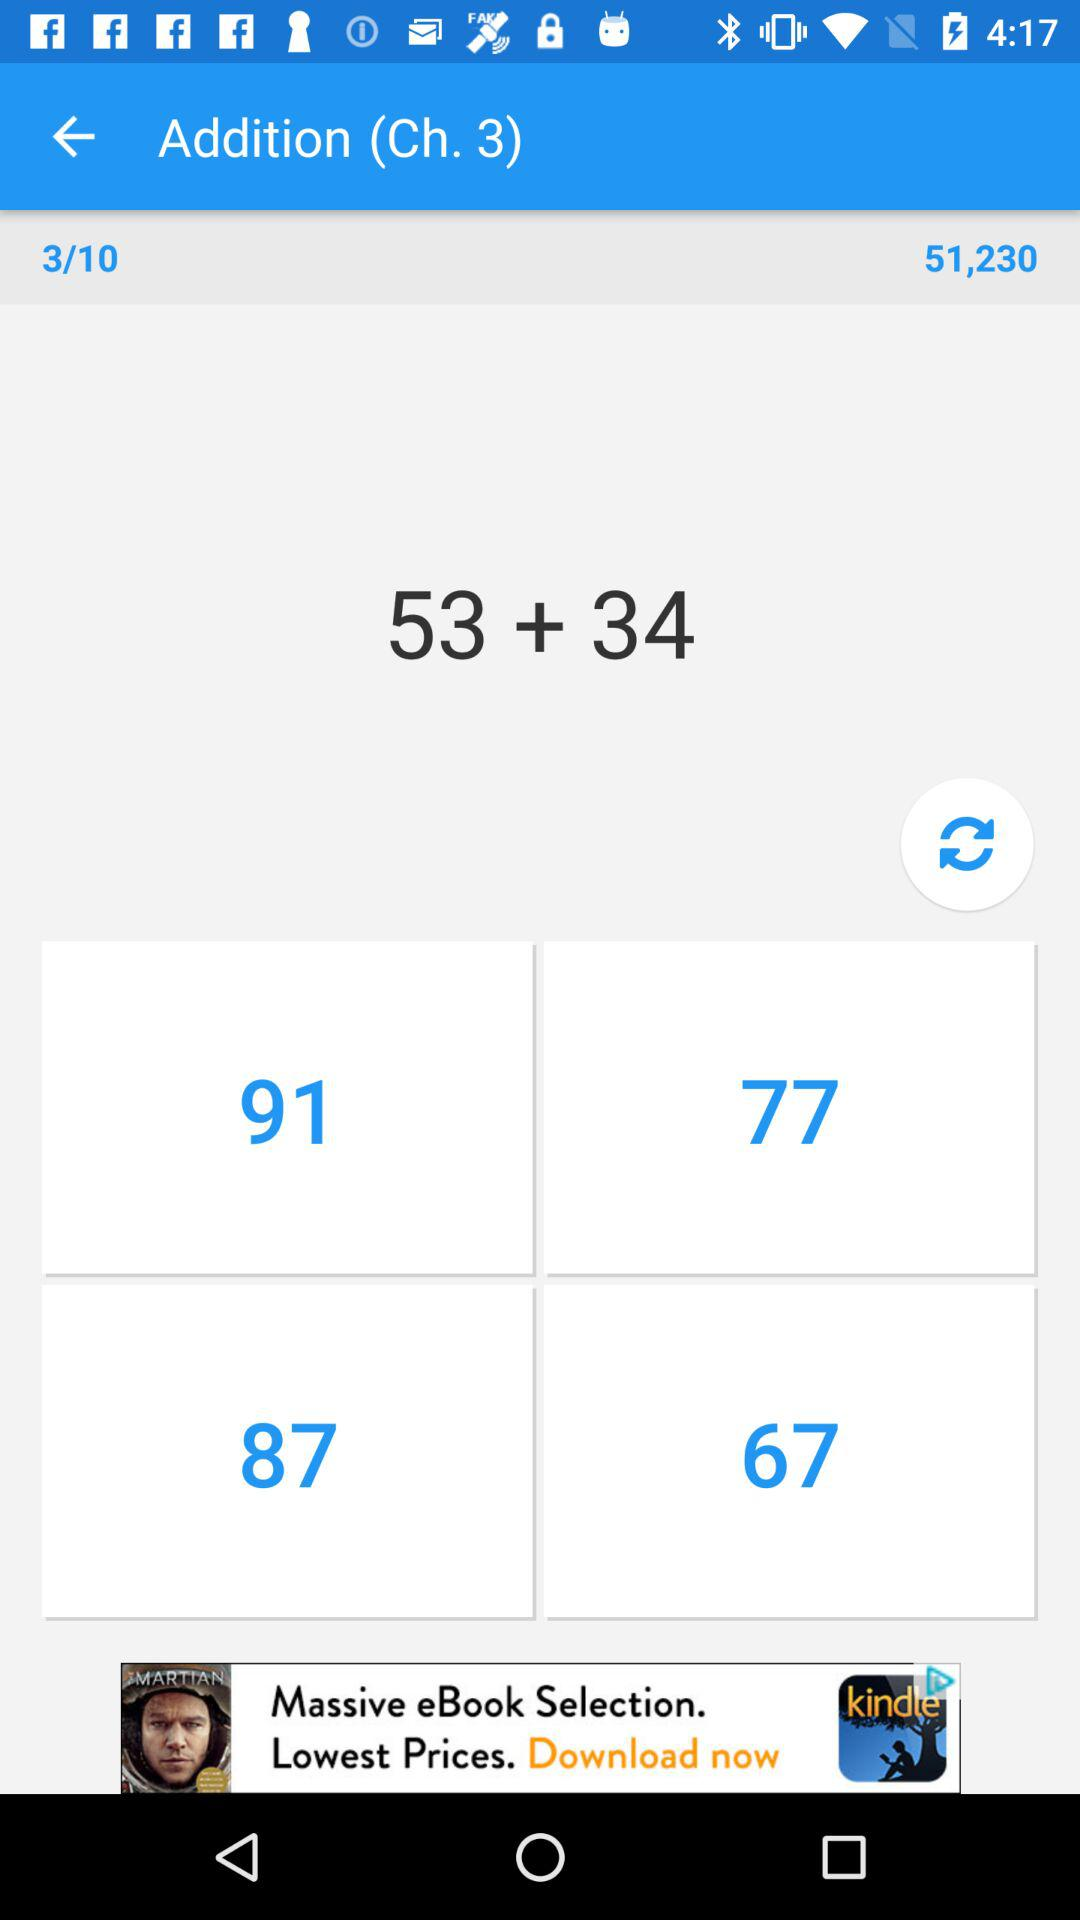What's the total number?
When the provided information is insufficient, respond with <no answer>. <no answer> 